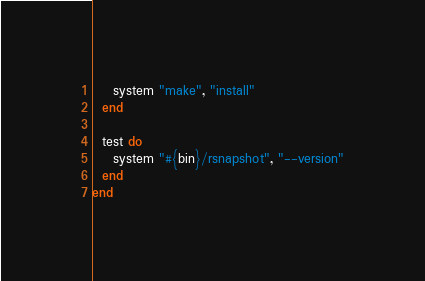Convert code to text. <code><loc_0><loc_0><loc_500><loc_500><_Ruby_>    system "make", "install"
  end

  test do
    system "#{bin}/rsnapshot", "--version"
  end
end
</code> 